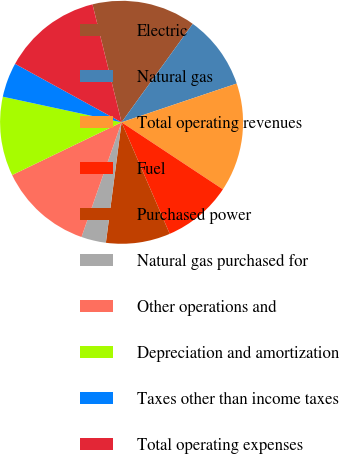<chart> <loc_0><loc_0><loc_500><loc_500><pie_chart><fcel>Electric<fcel>Natural gas<fcel>Total operating revenues<fcel>Fuel<fcel>Purchased power<fcel>Natural gas purchased for<fcel>Other operations and<fcel>Depreciation and amortization<fcel>Taxes other than income taxes<fcel>Total operating expenses<nl><fcel>13.81%<fcel>9.87%<fcel>14.47%<fcel>9.21%<fcel>8.55%<fcel>3.29%<fcel>12.5%<fcel>10.53%<fcel>4.61%<fcel>13.16%<nl></chart> 